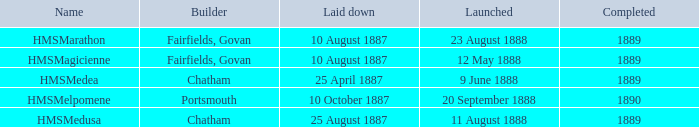What is the name of the boat that was built by Chatham and Laid down of 25 april 1887? HMSMedea. 